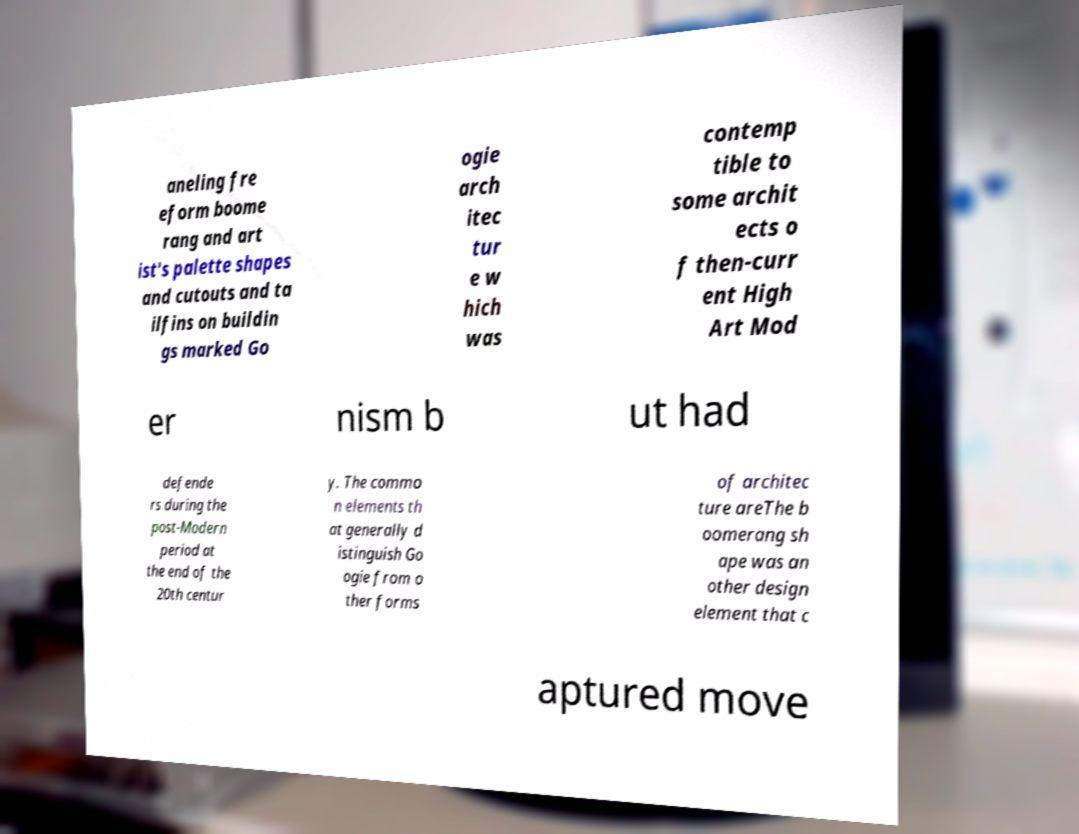What messages or text are displayed in this image? I need them in a readable, typed format. aneling fre eform boome rang and art ist's palette shapes and cutouts and ta ilfins on buildin gs marked Go ogie arch itec tur e w hich was contemp tible to some archit ects o f then-curr ent High Art Mod er nism b ut had defende rs during the post-Modern period at the end of the 20th centur y. The commo n elements th at generally d istinguish Go ogie from o ther forms of architec ture areThe b oomerang sh ape was an other design element that c aptured move 